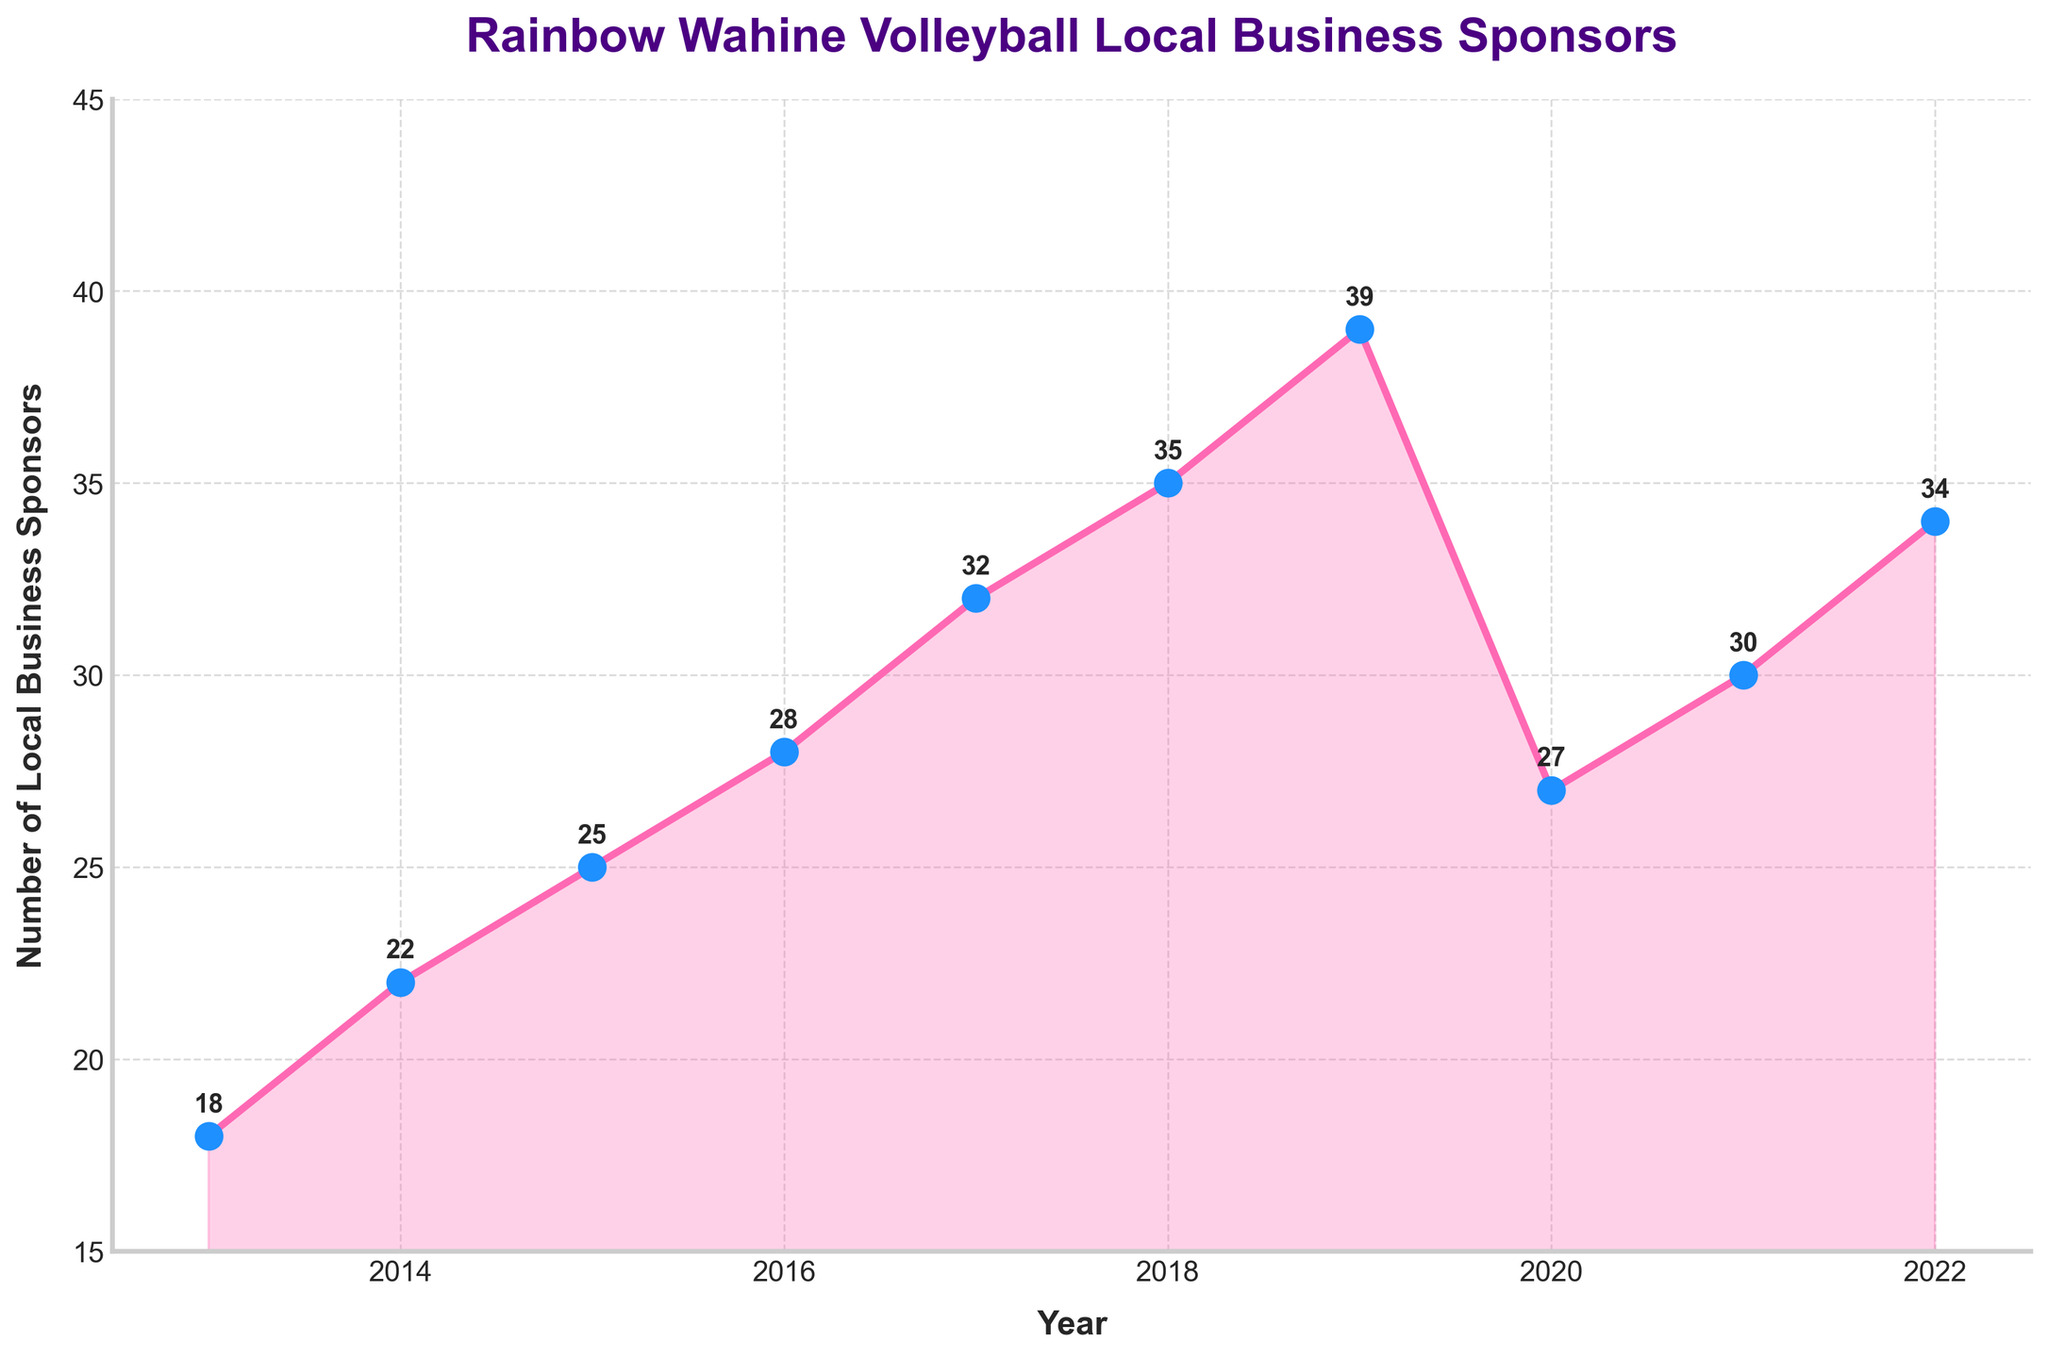how many local business sponsors were there in 2020? Refer to the data point for 2020 on the y-axis. The plot shows that there were 27 local business sponsors in 2020.
Answer: 27 Which year had the highest number of local business sponsors? Identify the highest point on the plot. The highest number of local business sponsors occurred in 2019, which had 39 sponsors.
Answer: 2019 By how many sponsors did the number of sponsors increase from 2013 to 2019? Find the difference between the number of sponsors in 2019 and 2013. The number increased from 18 in 2013 to 39 in 2019. The difference is 39 - 18 = 21.
Answer: 21 What is the average number of local business sponsors from 2013 to 2022? Sum all the number of sponsors from 2013 to 2022 and divide by the number of years. (18 + 22 + 25 + 28 + 32 + 35 + 39 + 27 + 30 + 34) / 10 = 290 / 10 = 29.
Answer: 29 In which year did the number of sponsors see the largest single-year increase, and what was the increase? Find the year-to-year differences and identify the largest one. 2013-2014: (22-18)=4, 2014-2015: (25-22)=3, 2015-2016: (28-25)=3, 2016-2017: (32-28)=4, 2017-2018: (35-32)=3, 2018-2019: (39-35)=4, 2019-2020: (27-39)=-12, 2020-2021: (30-27)=3, 2021-2022: (34-30)=4. The largest increase is from any one of the years 2013-2014, 2016-2017, or 2021-2022, each with an increase of 4 sponsors.
Answer: 2013-2014, 2016-2017, or 2021-2022, and 4 How does the number of sponsors in 2022 compare to 2020? Compare the data points for 2022 and 2020. In 2020 the number was 27, and in 2022 it was 34. 34 is greater than 27 by 7 sponsors.
Answer: 2022 is greater by 7 What is the trend observed from 2013 to 2019 before the sudden drop in 2020? Identify the general direction of the line from 2013 to 2019. The trend shows a steady increase each year from 18 in 2013 to 39 in 2019.
Answer: Steady increase What is the median number of sponsors from 2013 to 2022? List the number of sponsors in ascending order: 18, 22, 25, 27, 28, 30, 32, 34, 35, 39. The median is the middle value of this ordered list, which is the average of the 5th and 6th values: (28+30)/2 = 29.
Answer: 29 